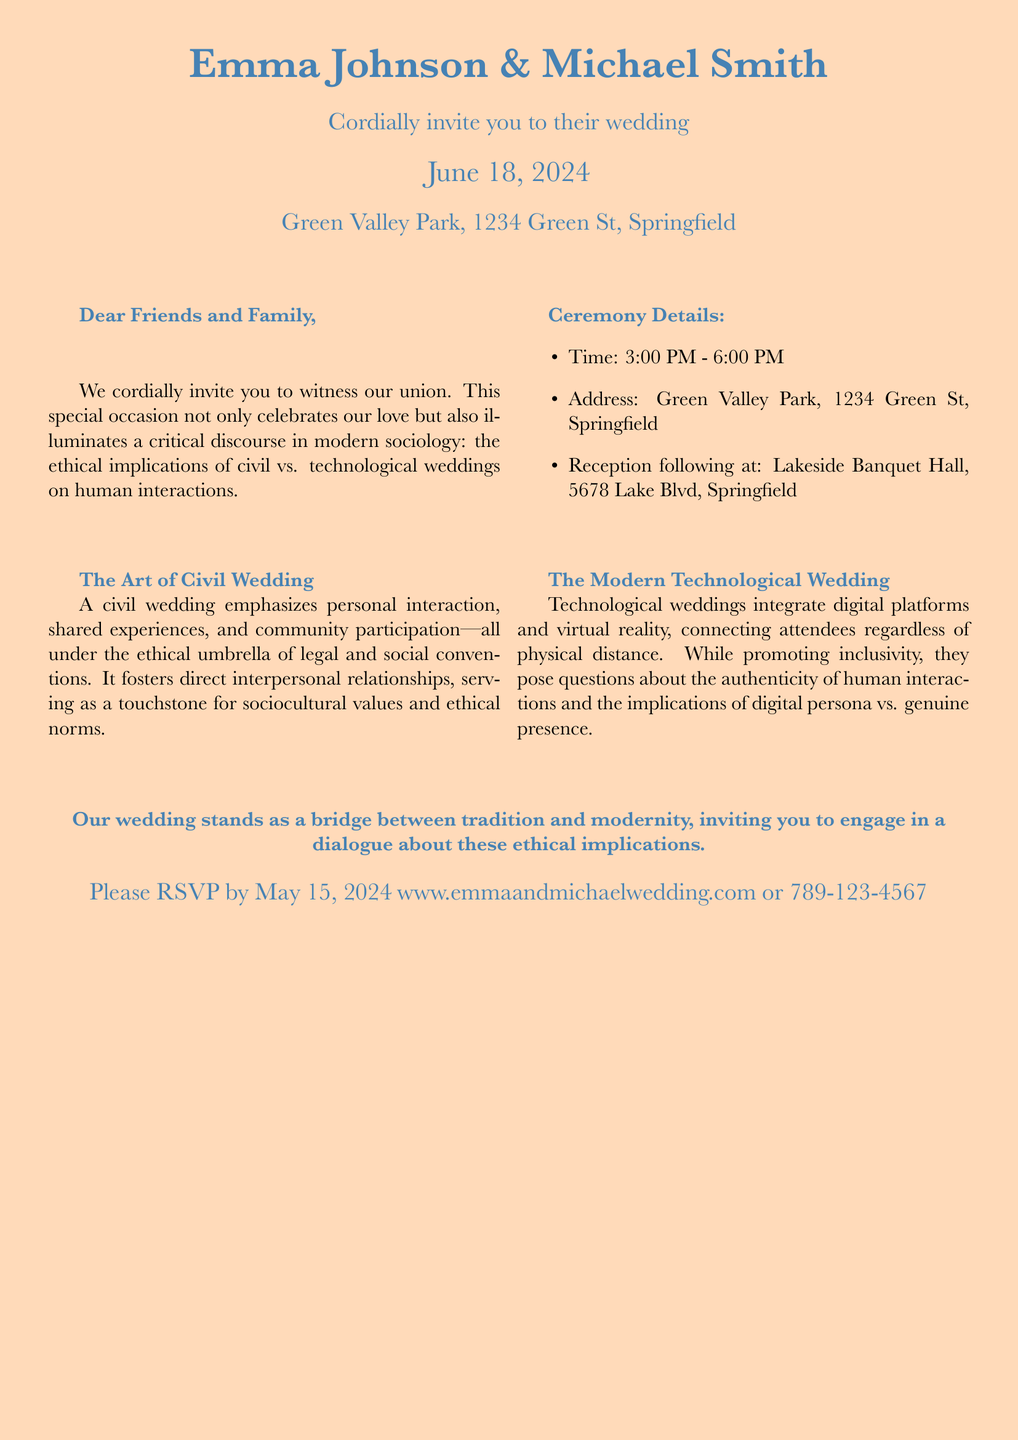What are the names of the couple? The document explicitly states the names at the top, "Emma Johnson & Michael Smith."
Answer: Emma Johnson & Michael Smith What is the wedding date? The wedding date is clearly indicated in the invitation under the couple's names.
Answer: June 18, 2024 Where is the wedding ceremony taking place? The location is mentioned in the document, specifically "Green Valley Park, 1234 Green St, Springfield."
Answer: Green Valley Park, 1234 Green St, Springfield What is the RSVP deadline? The document mentions a specific date for RSVPs, which is crucial for planning.
Answer: May 15, 2024 What ethical topic does the wedding highlight? The invitation notes the exploration of a critical discourse related to civil vs. technological weddings and human interactions.
Answer: Ethical implications on human interactions What is one characteristic of a civil wedding mentioned? The document states that a civil wedding emphasizes personal interaction and community participation.
Answer: Personal interaction What follows the wedding ceremony? The document specifies the continuation of the event after the ceremony.
Answer: Reception What does the modern technological wedding utilize? The invitation details that technological weddings integrate specific modern features.
Answer: Digital platforms and virtual reality What is the primary theme of the couples’ wedding? The invitation highlights the intention of their wedding in relation to traditional values and modernity.
Answer: A bridge between tradition and modernity 